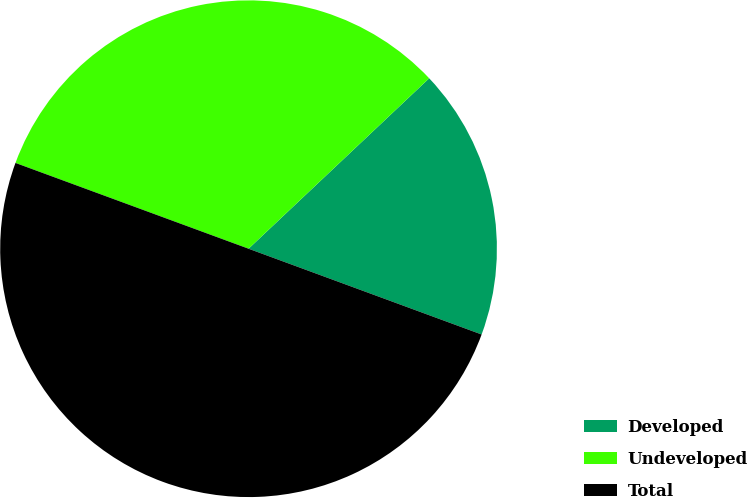Convert chart to OTSL. <chart><loc_0><loc_0><loc_500><loc_500><pie_chart><fcel>Developed<fcel>Undeveloped<fcel>Total<nl><fcel>17.65%<fcel>32.35%<fcel>50.0%<nl></chart> 